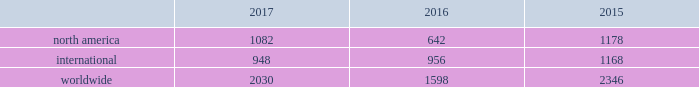Bhge 2017 form 10-k | 29 the rig counts are summarized in the table below as averages for each of the periods indicated. .
2017 compared to 2016 overall the rig count was 2030 in 2017 , an increase of 27% ( 27 % ) as compared to 2016 due primarily to north american activity .
The rig count in north america increased 69% ( 69 % ) in 2017 compared to 2016 .
Internationally , the rig count decreased 1% ( 1 % ) in 2017 as compared to the same period last year .
Within north america , the increase was primarily driven by the land rig count , which was up 72% ( 72 % ) , partially offset by a decrease in the offshore rig count of 16% ( 16 % ) .
Internationally , the rig count decrease was driven primarily by decreases in latin america of 7% ( 7 % ) , the europe region and africa region , which were down by 4% ( 4 % ) and 2% ( 2 % ) , respectively , partially offset by the asia-pacific region , which was up 8% ( 8 % ) .
2016 compared to 2015 overall the rig count was 1598 in 2016 , a decrease of 32% ( 32 % ) as compared to 2015 due primarily to north american activity .
The rig count in north america decreased 46% ( 46 % ) in 2016 compared to 2015 .
Internationally , the rig count decreased 18% ( 18 % ) in 2016 compared to 2015 .
Within north america , the decrease was primarily driven by a 44% ( 44 % ) decline in oil-directed rigs .
The natural gas- directed rig count in north america declined 50% ( 50 % ) in 2016 as natural gas well productivity improved .
Internationally , the rig count decrease was driven primarily by decreases in latin america , which was down 38% ( 38 % ) , the africa region , which was down 20% ( 20 % ) , and the europe region and asia-pacific region , which were down 18% ( 18 % ) and 15% ( 15 % ) , respectively .
Key performance indicators ( millions ) product services and backlog of product services our consolidated and combined statement of income ( loss ) displays sales and costs of sales in accordance with sec regulations under which "goods" is required to include all sales of tangible products and "services" must include all other sales , including other service activities .
For the amounts shown below , we distinguish between "equipment" and "product services" , where product services refer to sales under product services agreements , including sales of both goods ( such as spare parts and equipment upgrades ) and related services ( such as monitoring , maintenance and repairs ) , which is an important part of its operations .
We refer to "product services" simply as "services" within the business environment section of management's discussion and analysis .
Backlog is defined as unfilled customer orders for products and services believed to be firm .
For product services , an amount is included for the expected life of the contract. .
What portion of the rig counts is related to north america in 2016? 
Computations: (642 / 1598)
Answer: 0.40175. 